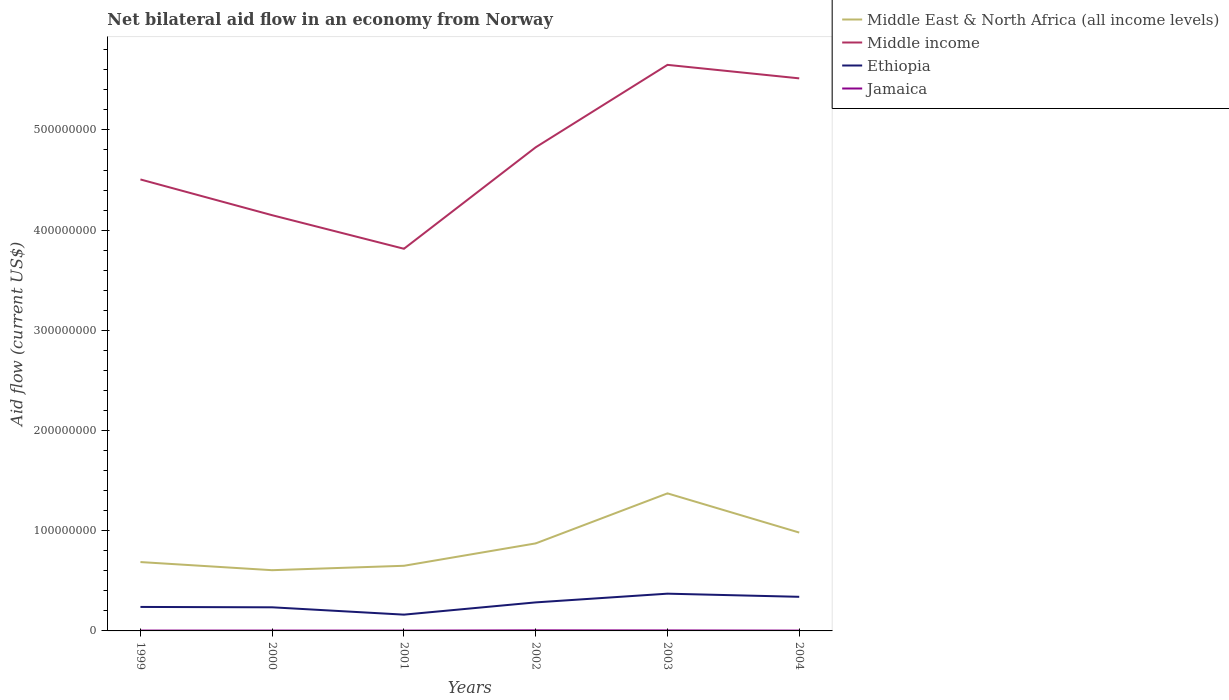How many different coloured lines are there?
Ensure brevity in your answer.  4. Does the line corresponding to Middle East & North Africa (all income levels) intersect with the line corresponding to Middle income?
Keep it short and to the point. No. Is the number of lines equal to the number of legend labels?
Your answer should be very brief. Yes. Across all years, what is the maximum net bilateral aid flow in Ethiopia?
Keep it short and to the point. 1.62e+07. What is the total net bilateral aid flow in Middle income in the graph?
Keep it short and to the point. 3.35e+07. What is the difference between the highest and the second highest net bilateral aid flow in Middle income?
Your response must be concise. 1.84e+08. Is the net bilateral aid flow in Middle East & North Africa (all income levels) strictly greater than the net bilateral aid flow in Jamaica over the years?
Offer a very short reply. No. How many years are there in the graph?
Offer a very short reply. 6. What is the difference between two consecutive major ticks on the Y-axis?
Give a very brief answer. 1.00e+08. Does the graph contain grids?
Provide a short and direct response. No. Where does the legend appear in the graph?
Keep it short and to the point. Top right. What is the title of the graph?
Your response must be concise. Net bilateral aid flow in an economy from Norway. Does "Tuvalu" appear as one of the legend labels in the graph?
Make the answer very short. No. What is the label or title of the X-axis?
Provide a succinct answer. Years. What is the label or title of the Y-axis?
Your answer should be very brief. Aid flow (current US$). What is the Aid flow (current US$) in Middle East & North Africa (all income levels) in 1999?
Your answer should be very brief. 6.87e+07. What is the Aid flow (current US$) of Middle income in 1999?
Ensure brevity in your answer.  4.51e+08. What is the Aid flow (current US$) of Ethiopia in 1999?
Offer a very short reply. 2.39e+07. What is the Aid flow (current US$) of Jamaica in 1999?
Ensure brevity in your answer.  3.60e+05. What is the Aid flow (current US$) of Middle East & North Africa (all income levels) in 2000?
Ensure brevity in your answer.  6.06e+07. What is the Aid flow (current US$) in Middle income in 2000?
Ensure brevity in your answer.  4.15e+08. What is the Aid flow (current US$) in Ethiopia in 2000?
Your answer should be compact. 2.36e+07. What is the Aid flow (current US$) of Jamaica in 2000?
Provide a short and direct response. 3.60e+05. What is the Aid flow (current US$) of Middle East & North Africa (all income levels) in 2001?
Your answer should be compact. 6.50e+07. What is the Aid flow (current US$) of Middle income in 2001?
Offer a terse response. 3.81e+08. What is the Aid flow (current US$) in Ethiopia in 2001?
Your answer should be compact. 1.62e+07. What is the Aid flow (current US$) in Middle East & North Africa (all income levels) in 2002?
Your answer should be very brief. 8.74e+07. What is the Aid flow (current US$) of Middle income in 2002?
Offer a terse response. 4.83e+08. What is the Aid flow (current US$) of Ethiopia in 2002?
Offer a very short reply. 2.85e+07. What is the Aid flow (current US$) in Jamaica in 2002?
Your response must be concise. 5.70e+05. What is the Aid flow (current US$) of Middle East & North Africa (all income levels) in 2003?
Ensure brevity in your answer.  1.37e+08. What is the Aid flow (current US$) of Middle income in 2003?
Offer a terse response. 5.65e+08. What is the Aid flow (current US$) of Ethiopia in 2003?
Offer a terse response. 3.72e+07. What is the Aid flow (current US$) in Jamaica in 2003?
Keep it short and to the point. 5.00e+05. What is the Aid flow (current US$) of Middle East & North Africa (all income levels) in 2004?
Make the answer very short. 9.82e+07. What is the Aid flow (current US$) in Middle income in 2004?
Offer a very short reply. 5.52e+08. What is the Aid flow (current US$) in Ethiopia in 2004?
Your response must be concise. 3.40e+07. What is the Aid flow (current US$) in Jamaica in 2004?
Give a very brief answer. 3.30e+05. Across all years, what is the maximum Aid flow (current US$) in Middle East & North Africa (all income levels)?
Keep it short and to the point. 1.37e+08. Across all years, what is the maximum Aid flow (current US$) of Middle income?
Make the answer very short. 5.65e+08. Across all years, what is the maximum Aid flow (current US$) of Ethiopia?
Keep it short and to the point. 3.72e+07. Across all years, what is the maximum Aid flow (current US$) of Jamaica?
Keep it short and to the point. 5.70e+05. Across all years, what is the minimum Aid flow (current US$) of Middle East & North Africa (all income levels)?
Your response must be concise. 6.06e+07. Across all years, what is the minimum Aid flow (current US$) of Middle income?
Provide a short and direct response. 3.81e+08. Across all years, what is the minimum Aid flow (current US$) of Ethiopia?
Offer a very short reply. 1.62e+07. Across all years, what is the minimum Aid flow (current US$) of Jamaica?
Your answer should be compact. 3.10e+05. What is the total Aid flow (current US$) in Middle East & North Africa (all income levels) in the graph?
Your response must be concise. 5.17e+08. What is the total Aid flow (current US$) in Middle income in the graph?
Keep it short and to the point. 2.85e+09. What is the total Aid flow (current US$) of Ethiopia in the graph?
Provide a succinct answer. 1.63e+08. What is the total Aid flow (current US$) of Jamaica in the graph?
Provide a succinct answer. 2.43e+06. What is the difference between the Aid flow (current US$) of Middle East & North Africa (all income levels) in 1999 and that in 2000?
Your response must be concise. 8.12e+06. What is the difference between the Aid flow (current US$) in Middle income in 1999 and that in 2000?
Ensure brevity in your answer.  3.57e+07. What is the difference between the Aid flow (current US$) in Ethiopia in 1999 and that in 2000?
Keep it short and to the point. 3.60e+05. What is the difference between the Aid flow (current US$) of Jamaica in 1999 and that in 2000?
Your answer should be compact. 0. What is the difference between the Aid flow (current US$) of Middle East & North Africa (all income levels) in 1999 and that in 2001?
Keep it short and to the point. 3.72e+06. What is the difference between the Aid flow (current US$) of Middle income in 1999 and that in 2001?
Make the answer very short. 6.92e+07. What is the difference between the Aid flow (current US$) in Ethiopia in 1999 and that in 2001?
Ensure brevity in your answer.  7.68e+06. What is the difference between the Aid flow (current US$) of Jamaica in 1999 and that in 2001?
Provide a succinct answer. 5.00e+04. What is the difference between the Aid flow (current US$) in Middle East & North Africa (all income levels) in 1999 and that in 2002?
Provide a short and direct response. -1.86e+07. What is the difference between the Aid flow (current US$) of Middle income in 1999 and that in 2002?
Give a very brief answer. -3.21e+07. What is the difference between the Aid flow (current US$) of Ethiopia in 1999 and that in 2002?
Ensure brevity in your answer.  -4.55e+06. What is the difference between the Aid flow (current US$) in Middle East & North Africa (all income levels) in 1999 and that in 2003?
Offer a very short reply. -6.86e+07. What is the difference between the Aid flow (current US$) in Middle income in 1999 and that in 2003?
Provide a succinct answer. -1.14e+08. What is the difference between the Aid flow (current US$) of Ethiopia in 1999 and that in 2003?
Give a very brief answer. -1.32e+07. What is the difference between the Aid flow (current US$) in Middle East & North Africa (all income levels) in 1999 and that in 2004?
Ensure brevity in your answer.  -2.94e+07. What is the difference between the Aid flow (current US$) in Middle income in 1999 and that in 2004?
Offer a very short reply. -1.01e+08. What is the difference between the Aid flow (current US$) in Ethiopia in 1999 and that in 2004?
Provide a short and direct response. -1.01e+07. What is the difference between the Aid flow (current US$) in Middle East & North Africa (all income levels) in 2000 and that in 2001?
Your response must be concise. -4.40e+06. What is the difference between the Aid flow (current US$) of Middle income in 2000 and that in 2001?
Keep it short and to the point. 3.35e+07. What is the difference between the Aid flow (current US$) in Ethiopia in 2000 and that in 2001?
Offer a terse response. 7.32e+06. What is the difference between the Aid flow (current US$) of Jamaica in 2000 and that in 2001?
Offer a very short reply. 5.00e+04. What is the difference between the Aid flow (current US$) in Middle East & North Africa (all income levels) in 2000 and that in 2002?
Ensure brevity in your answer.  -2.68e+07. What is the difference between the Aid flow (current US$) of Middle income in 2000 and that in 2002?
Offer a very short reply. -6.78e+07. What is the difference between the Aid flow (current US$) in Ethiopia in 2000 and that in 2002?
Provide a short and direct response. -4.91e+06. What is the difference between the Aid flow (current US$) in Jamaica in 2000 and that in 2002?
Your response must be concise. -2.10e+05. What is the difference between the Aid flow (current US$) in Middle East & North Africa (all income levels) in 2000 and that in 2003?
Your answer should be very brief. -7.67e+07. What is the difference between the Aid flow (current US$) in Middle income in 2000 and that in 2003?
Your answer should be very brief. -1.50e+08. What is the difference between the Aid flow (current US$) in Ethiopia in 2000 and that in 2003?
Give a very brief answer. -1.36e+07. What is the difference between the Aid flow (current US$) in Jamaica in 2000 and that in 2003?
Provide a short and direct response. -1.40e+05. What is the difference between the Aid flow (current US$) in Middle East & North Africa (all income levels) in 2000 and that in 2004?
Make the answer very short. -3.76e+07. What is the difference between the Aid flow (current US$) in Middle income in 2000 and that in 2004?
Provide a succinct answer. -1.37e+08. What is the difference between the Aid flow (current US$) in Ethiopia in 2000 and that in 2004?
Offer a terse response. -1.05e+07. What is the difference between the Aid flow (current US$) in Jamaica in 2000 and that in 2004?
Your response must be concise. 3.00e+04. What is the difference between the Aid flow (current US$) in Middle East & North Africa (all income levels) in 2001 and that in 2002?
Offer a terse response. -2.24e+07. What is the difference between the Aid flow (current US$) in Middle income in 2001 and that in 2002?
Your answer should be compact. -1.01e+08. What is the difference between the Aid flow (current US$) of Ethiopia in 2001 and that in 2002?
Give a very brief answer. -1.22e+07. What is the difference between the Aid flow (current US$) of Jamaica in 2001 and that in 2002?
Provide a short and direct response. -2.60e+05. What is the difference between the Aid flow (current US$) of Middle East & North Africa (all income levels) in 2001 and that in 2003?
Your answer should be compact. -7.23e+07. What is the difference between the Aid flow (current US$) in Middle income in 2001 and that in 2003?
Give a very brief answer. -1.84e+08. What is the difference between the Aid flow (current US$) of Ethiopia in 2001 and that in 2003?
Offer a very short reply. -2.09e+07. What is the difference between the Aid flow (current US$) in Jamaica in 2001 and that in 2003?
Your answer should be very brief. -1.90e+05. What is the difference between the Aid flow (current US$) in Middle East & North Africa (all income levels) in 2001 and that in 2004?
Your answer should be compact. -3.32e+07. What is the difference between the Aid flow (current US$) of Middle income in 2001 and that in 2004?
Your response must be concise. -1.70e+08. What is the difference between the Aid flow (current US$) in Ethiopia in 2001 and that in 2004?
Your answer should be compact. -1.78e+07. What is the difference between the Aid flow (current US$) of Middle East & North Africa (all income levels) in 2002 and that in 2003?
Make the answer very short. -4.99e+07. What is the difference between the Aid flow (current US$) in Middle income in 2002 and that in 2003?
Your answer should be very brief. -8.23e+07. What is the difference between the Aid flow (current US$) in Ethiopia in 2002 and that in 2003?
Ensure brevity in your answer.  -8.70e+06. What is the difference between the Aid flow (current US$) of Middle East & North Africa (all income levels) in 2002 and that in 2004?
Offer a very short reply. -1.08e+07. What is the difference between the Aid flow (current US$) in Middle income in 2002 and that in 2004?
Ensure brevity in your answer.  -6.88e+07. What is the difference between the Aid flow (current US$) of Ethiopia in 2002 and that in 2004?
Offer a very short reply. -5.56e+06. What is the difference between the Aid flow (current US$) of Jamaica in 2002 and that in 2004?
Offer a very short reply. 2.40e+05. What is the difference between the Aid flow (current US$) in Middle East & North Africa (all income levels) in 2003 and that in 2004?
Your response must be concise. 3.91e+07. What is the difference between the Aid flow (current US$) of Middle income in 2003 and that in 2004?
Your answer should be very brief. 1.35e+07. What is the difference between the Aid flow (current US$) of Ethiopia in 2003 and that in 2004?
Keep it short and to the point. 3.14e+06. What is the difference between the Aid flow (current US$) in Jamaica in 2003 and that in 2004?
Your response must be concise. 1.70e+05. What is the difference between the Aid flow (current US$) in Middle East & North Africa (all income levels) in 1999 and the Aid flow (current US$) in Middle income in 2000?
Your response must be concise. -3.46e+08. What is the difference between the Aid flow (current US$) in Middle East & North Africa (all income levels) in 1999 and the Aid flow (current US$) in Ethiopia in 2000?
Give a very brief answer. 4.52e+07. What is the difference between the Aid flow (current US$) in Middle East & North Africa (all income levels) in 1999 and the Aid flow (current US$) in Jamaica in 2000?
Your answer should be very brief. 6.84e+07. What is the difference between the Aid flow (current US$) in Middle income in 1999 and the Aid flow (current US$) in Ethiopia in 2000?
Your response must be concise. 4.27e+08. What is the difference between the Aid flow (current US$) of Middle income in 1999 and the Aid flow (current US$) of Jamaica in 2000?
Ensure brevity in your answer.  4.50e+08. What is the difference between the Aid flow (current US$) in Ethiopia in 1999 and the Aid flow (current US$) in Jamaica in 2000?
Provide a succinct answer. 2.36e+07. What is the difference between the Aid flow (current US$) of Middle East & North Africa (all income levels) in 1999 and the Aid flow (current US$) of Middle income in 2001?
Keep it short and to the point. -3.13e+08. What is the difference between the Aid flow (current US$) in Middle East & North Africa (all income levels) in 1999 and the Aid flow (current US$) in Ethiopia in 2001?
Make the answer very short. 5.25e+07. What is the difference between the Aid flow (current US$) of Middle East & North Africa (all income levels) in 1999 and the Aid flow (current US$) of Jamaica in 2001?
Keep it short and to the point. 6.84e+07. What is the difference between the Aid flow (current US$) of Middle income in 1999 and the Aid flow (current US$) of Ethiopia in 2001?
Your answer should be very brief. 4.34e+08. What is the difference between the Aid flow (current US$) in Middle income in 1999 and the Aid flow (current US$) in Jamaica in 2001?
Ensure brevity in your answer.  4.50e+08. What is the difference between the Aid flow (current US$) of Ethiopia in 1999 and the Aid flow (current US$) of Jamaica in 2001?
Provide a succinct answer. 2.36e+07. What is the difference between the Aid flow (current US$) in Middle East & North Africa (all income levels) in 1999 and the Aid flow (current US$) in Middle income in 2002?
Make the answer very short. -4.14e+08. What is the difference between the Aid flow (current US$) in Middle East & North Africa (all income levels) in 1999 and the Aid flow (current US$) in Ethiopia in 2002?
Give a very brief answer. 4.02e+07. What is the difference between the Aid flow (current US$) in Middle East & North Africa (all income levels) in 1999 and the Aid flow (current US$) in Jamaica in 2002?
Offer a very short reply. 6.82e+07. What is the difference between the Aid flow (current US$) of Middle income in 1999 and the Aid flow (current US$) of Ethiopia in 2002?
Provide a short and direct response. 4.22e+08. What is the difference between the Aid flow (current US$) of Middle income in 1999 and the Aid flow (current US$) of Jamaica in 2002?
Your response must be concise. 4.50e+08. What is the difference between the Aid flow (current US$) in Ethiopia in 1999 and the Aid flow (current US$) in Jamaica in 2002?
Your answer should be compact. 2.34e+07. What is the difference between the Aid flow (current US$) in Middle East & North Africa (all income levels) in 1999 and the Aid flow (current US$) in Middle income in 2003?
Provide a succinct answer. -4.96e+08. What is the difference between the Aid flow (current US$) in Middle East & North Africa (all income levels) in 1999 and the Aid flow (current US$) in Ethiopia in 2003?
Ensure brevity in your answer.  3.16e+07. What is the difference between the Aid flow (current US$) in Middle East & North Africa (all income levels) in 1999 and the Aid flow (current US$) in Jamaica in 2003?
Your answer should be compact. 6.82e+07. What is the difference between the Aid flow (current US$) in Middle income in 1999 and the Aid flow (current US$) in Ethiopia in 2003?
Provide a short and direct response. 4.13e+08. What is the difference between the Aid flow (current US$) in Middle income in 1999 and the Aid flow (current US$) in Jamaica in 2003?
Make the answer very short. 4.50e+08. What is the difference between the Aid flow (current US$) of Ethiopia in 1999 and the Aid flow (current US$) of Jamaica in 2003?
Offer a terse response. 2.34e+07. What is the difference between the Aid flow (current US$) in Middle East & North Africa (all income levels) in 1999 and the Aid flow (current US$) in Middle income in 2004?
Your answer should be very brief. -4.83e+08. What is the difference between the Aid flow (current US$) in Middle East & North Africa (all income levels) in 1999 and the Aid flow (current US$) in Ethiopia in 2004?
Provide a short and direct response. 3.47e+07. What is the difference between the Aid flow (current US$) of Middle East & North Africa (all income levels) in 1999 and the Aid flow (current US$) of Jamaica in 2004?
Provide a short and direct response. 6.84e+07. What is the difference between the Aid flow (current US$) in Middle income in 1999 and the Aid flow (current US$) in Ethiopia in 2004?
Offer a very short reply. 4.17e+08. What is the difference between the Aid flow (current US$) of Middle income in 1999 and the Aid flow (current US$) of Jamaica in 2004?
Your response must be concise. 4.50e+08. What is the difference between the Aid flow (current US$) of Ethiopia in 1999 and the Aid flow (current US$) of Jamaica in 2004?
Provide a succinct answer. 2.36e+07. What is the difference between the Aid flow (current US$) of Middle East & North Africa (all income levels) in 2000 and the Aid flow (current US$) of Middle income in 2001?
Ensure brevity in your answer.  -3.21e+08. What is the difference between the Aid flow (current US$) in Middle East & North Africa (all income levels) in 2000 and the Aid flow (current US$) in Ethiopia in 2001?
Make the answer very short. 4.44e+07. What is the difference between the Aid flow (current US$) in Middle East & North Africa (all income levels) in 2000 and the Aid flow (current US$) in Jamaica in 2001?
Provide a succinct answer. 6.03e+07. What is the difference between the Aid flow (current US$) of Middle income in 2000 and the Aid flow (current US$) of Ethiopia in 2001?
Give a very brief answer. 3.99e+08. What is the difference between the Aid flow (current US$) of Middle income in 2000 and the Aid flow (current US$) of Jamaica in 2001?
Offer a very short reply. 4.15e+08. What is the difference between the Aid flow (current US$) in Ethiopia in 2000 and the Aid flow (current US$) in Jamaica in 2001?
Make the answer very short. 2.33e+07. What is the difference between the Aid flow (current US$) of Middle East & North Africa (all income levels) in 2000 and the Aid flow (current US$) of Middle income in 2002?
Provide a short and direct response. -4.22e+08. What is the difference between the Aid flow (current US$) in Middle East & North Africa (all income levels) in 2000 and the Aid flow (current US$) in Ethiopia in 2002?
Offer a terse response. 3.21e+07. What is the difference between the Aid flow (current US$) in Middle East & North Africa (all income levels) in 2000 and the Aid flow (current US$) in Jamaica in 2002?
Your answer should be compact. 6.00e+07. What is the difference between the Aid flow (current US$) of Middle income in 2000 and the Aid flow (current US$) of Ethiopia in 2002?
Offer a terse response. 3.86e+08. What is the difference between the Aid flow (current US$) of Middle income in 2000 and the Aid flow (current US$) of Jamaica in 2002?
Ensure brevity in your answer.  4.14e+08. What is the difference between the Aid flow (current US$) in Ethiopia in 2000 and the Aid flow (current US$) in Jamaica in 2002?
Your response must be concise. 2.30e+07. What is the difference between the Aid flow (current US$) in Middle East & North Africa (all income levels) in 2000 and the Aid flow (current US$) in Middle income in 2003?
Provide a succinct answer. -5.04e+08. What is the difference between the Aid flow (current US$) of Middle East & North Africa (all income levels) in 2000 and the Aid flow (current US$) of Ethiopia in 2003?
Provide a short and direct response. 2.34e+07. What is the difference between the Aid flow (current US$) of Middle East & North Africa (all income levels) in 2000 and the Aid flow (current US$) of Jamaica in 2003?
Your answer should be compact. 6.01e+07. What is the difference between the Aid flow (current US$) of Middle income in 2000 and the Aid flow (current US$) of Ethiopia in 2003?
Provide a short and direct response. 3.78e+08. What is the difference between the Aid flow (current US$) of Middle income in 2000 and the Aid flow (current US$) of Jamaica in 2003?
Provide a short and direct response. 4.14e+08. What is the difference between the Aid flow (current US$) in Ethiopia in 2000 and the Aid flow (current US$) in Jamaica in 2003?
Provide a short and direct response. 2.31e+07. What is the difference between the Aid flow (current US$) in Middle East & North Africa (all income levels) in 2000 and the Aid flow (current US$) in Middle income in 2004?
Give a very brief answer. -4.91e+08. What is the difference between the Aid flow (current US$) in Middle East & North Africa (all income levels) in 2000 and the Aid flow (current US$) in Ethiopia in 2004?
Offer a terse response. 2.66e+07. What is the difference between the Aid flow (current US$) of Middle East & North Africa (all income levels) in 2000 and the Aid flow (current US$) of Jamaica in 2004?
Your response must be concise. 6.03e+07. What is the difference between the Aid flow (current US$) of Middle income in 2000 and the Aid flow (current US$) of Ethiopia in 2004?
Your answer should be compact. 3.81e+08. What is the difference between the Aid flow (current US$) in Middle income in 2000 and the Aid flow (current US$) in Jamaica in 2004?
Make the answer very short. 4.15e+08. What is the difference between the Aid flow (current US$) in Ethiopia in 2000 and the Aid flow (current US$) in Jamaica in 2004?
Offer a very short reply. 2.32e+07. What is the difference between the Aid flow (current US$) in Middle East & North Africa (all income levels) in 2001 and the Aid flow (current US$) in Middle income in 2002?
Provide a succinct answer. -4.18e+08. What is the difference between the Aid flow (current US$) of Middle East & North Africa (all income levels) in 2001 and the Aid flow (current US$) of Ethiopia in 2002?
Your answer should be very brief. 3.65e+07. What is the difference between the Aid flow (current US$) in Middle East & North Africa (all income levels) in 2001 and the Aid flow (current US$) in Jamaica in 2002?
Provide a short and direct response. 6.44e+07. What is the difference between the Aid flow (current US$) of Middle income in 2001 and the Aid flow (current US$) of Ethiopia in 2002?
Provide a succinct answer. 3.53e+08. What is the difference between the Aid flow (current US$) in Middle income in 2001 and the Aid flow (current US$) in Jamaica in 2002?
Provide a succinct answer. 3.81e+08. What is the difference between the Aid flow (current US$) in Ethiopia in 2001 and the Aid flow (current US$) in Jamaica in 2002?
Ensure brevity in your answer.  1.57e+07. What is the difference between the Aid flow (current US$) in Middle East & North Africa (all income levels) in 2001 and the Aid flow (current US$) in Middle income in 2003?
Offer a very short reply. -5.00e+08. What is the difference between the Aid flow (current US$) in Middle East & North Africa (all income levels) in 2001 and the Aid flow (current US$) in Ethiopia in 2003?
Make the answer very short. 2.78e+07. What is the difference between the Aid flow (current US$) in Middle East & North Africa (all income levels) in 2001 and the Aid flow (current US$) in Jamaica in 2003?
Give a very brief answer. 6.45e+07. What is the difference between the Aid flow (current US$) in Middle income in 2001 and the Aid flow (current US$) in Ethiopia in 2003?
Offer a very short reply. 3.44e+08. What is the difference between the Aid flow (current US$) in Middle income in 2001 and the Aid flow (current US$) in Jamaica in 2003?
Offer a terse response. 3.81e+08. What is the difference between the Aid flow (current US$) of Ethiopia in 2001 and the Aid flow (current US$) of Jamaica in 2003?
Keep it short and to the point. 1.58e+07. What is the difference between the Aid flow (current US$) of Middle East & North Africa (all income levels) in 2001 and the Aid flow (current US$) of Middle income in 2004?
Ensure brevity in your answer.  -4.86e+08. What is the difference between the Aid flow (current US$) of Middle East & North Africa (all income levels) in 2001 and the Aid flow (current US$) of Ethiopia in 2004?
Provide a succinct answer. 3.10e+07. What is the difference between the Aid flow (current US$) of Middle East & North Africa (all income levels) in 2001 and the Aid flow (current US$) of Jamaica in 2004?
Your answer should be very brief. 6.47e+07. What is the difference between the Aid flow (current US$) in Middle income in 2001 and the Aid flow (current US$) in Ethiopia in 2004?
Keep it short and to the point. 3.47e+08. What is the difference between the Aid flow (current US$) in Middle income in 2001 and the Aid flow (current US$) in Jamaica in 2004?
Your answer should be compact. 3.81e+08. What is the difference between the Aid flow (current US$) in Ethiopia in 2001 and the Aid flow (current US$) in Jamaica in 2004?
Offer a very short reply. 1.59e+07. What is the difference between the Aid flow (current US$) of Middle East & North Africa (all income levels) in 2002 and the Aid flow (current US$) of Middle income in 2003?
Provide a succinct answer. -4.78e+08. What is the difference between the Aid flow (current US$) of Middle East & North Africa (all income levels) in 2002 and the Aid flow (current US$) of Ethiopia in 2003?
Provide a short and direct response. 5.02e+07. What is the difference between the Aid flow (current US$) of Middle East & North Africa (all income levels) in 2002 and the Aid flow (current US$) of Jamaica in 2003?
Your answer should be compact. 8.69e+07. What is the difference between the Aid flow (current US$) in Middle income in 2002 and the Aid flow (current US$) in Ethiopia in 2003?
Offer a very short reply. 4.46e+08. What is the difference between the Aid flow (current US$) in Middle income in 2002 and the Aid flow (current US$) in Jamaica in 2003?
Keep it short and to the point. 4.82e+08. What is the difference between the Aid flow (current US$) in Ethiopia in 2002 and the Aid flow (current US$) in Jamaica in 2003?
Ensure brevity in your answer.  2.80e+07. What is the difference between the Aid flow (current US$) in Middle East & North Africa (all income levels) in 2002 and the Aid flow (current US$) in Middle income in 2004?
Give a very brief answer. -4.64e+08. What is the difference between the Aid flow (current US$) in Middle East & North Africa (all income levels) in 2002 and the Aid flow (current US$) in Ethiopia in 2004?
Keep it short and to the point. 5.33e+07. What is the difference between the Aid flow (current US$) in Middle East & North Africa (all income levels) in 2002 and the Aid flow (current US$) in Jamaica in 2004?
Your answer should be very brief. 8.70e+07. What is the difference between the Aid flow (current US$) of Middle income in 2002 and the Aid flow (current US$) of Ethiopia in 2004?
Your answer should be very brief. 4.49e+08. What is the difference between the Aid flow (current US$) of Middle income in 2002 and the Aid flow (current US$) of Jamaica in 2004?
Your answer should be very brief. 4.82e+08. What is the difference between the Aid flow (current US$) in Ethiopia in 2002 and the Aid flow (current US$) in Jamaica in 2004?
Your answer should be very brief. 2.82e+07. What is the difference between the Aid flow (current US$) of Middle East & North Africa (all income levels) in 2003 and the Aid flow (current US$) of Middle income in 2004?
Keep it short and to the point. -4.14e+08. What is the difference between the Aid flow (current US$) of Middle East & North Africa (all income levels) in 2003 and the Aid flow (current US$) of Ethiopia in 2004?
Provide a succinct answer. 1.03e+08. What is the difference between the Aid flow (current US$) of Middle East & North Africa (all income levels) in 2003 and the Aid flow (current US$) of Jamaica in 2004?
Offer a very short reply. 1.37e+08. What is the difference between the Aid flow (current US$) in Middle income in 2003 and the Aid flow (current US$) in Ethiopia in 2004?
Ensure brevity in your answer.  5.31e+08. What is the difference between the Aid flow (current US$) in Middle income in 2003 and the Aid flow (current US$) in Jamaica in 2004?
Provide a short and direct response. 5.65e+08. What is the difference between the Aid flow (current US$) in Ethiopia in 2003 and the Aid flow (current US$) in Jamaica in 2004?
Your answer should be very brief. 3.68e+07. What is the average Aid flow (current US$) of Middle East & North Africa (all income levels) per year?
Offer a very short reply. 8.62e+07. What is the average Aid flow (current US$) in Middle income per year?
Provide a short and direct response. 4.74e+08. What is the average Aid flow (current US$) of Ethiopia per year?
Your response must be concise. 2.72e+07. What is the average Aid flow (current US$) of Jamaica per year?
Your answer should be very brief. 4.05e+05. In the year 1999, what is the difference between the Aid flow (current US$) of Middle East & North Africa (all income levels) and Aid flow (current US$) of Middle income?
Your answer should be very brief. -3.82e+08. In the year 1999, what is the difference between the Aid flow (current US$) of Middle East & North Africa (all income levels) and Aid flow (current US$) of Ethiopia?
Keep it short and to the point. 4.48e+07. In the year 1999, what is the difference between the Aid flow (current US$) of Middle East & North Africa (all income levels) and Aid flow (current US$) of Jamaica?
Offer a very short reply. 6.84e+07. In the year 1999, what is the difference between the Aid flow (current US$) in Middle income and Aid flow (current US$) in Ethiopia?
Provide a short and direct response. 4.27e+08. In the year 1999, what is the difference between the Aid flow (current US$) in Middle income and Aid flow (current US$) in Jamaica?
Your answer should be very brief. 4.50e+08. In the year 1999, what is the difference between the Aid flow (current US$) in Ethiopia and Aid flow (current US$) in Jamaica?
Ensure brevity in your answer.  2.36e+07. In the year 2000, what is the difference between the Aid flow (current US$) of Middle East & North Africa (all income levels) and Aid flow (current US$) of Middle income?
Ensure brevity in your answer.  -3.54e+08. In the year 2000, what is the difference between the Aid flow (current US$) of Middle East & North Africa (all income levels) and Aid flow (current US$) of Ethiopia?
Your response must be concise. 3.70e+07. In the year 2000, what is the difference between the Aid flow (current US$) in Middle East & North Africa (all income levels) and Aid flow (current US$) in Jamaica?
Your answer should be very brief. 6.02e+07. In the year 2000, what is the difference between the Aid flow (current US$) in Middle income and Aid flow (current US$) in Ethiopia?
Make the answer very short. 3.91e+08. In the year 2000, what is the difference between the Aid flow (current US$) of Middle income and Aid flow (current US$) of Jamaica?
Keep it short and to the point. 4.15e+08. In the year 2000, what is the difference between the Aid flow (current US$) of Ethiopia and Aid flow (current US$) of Jamaica?
Offer a very short reply. 2.32e+07. In the year 2001, what is the difference between the Aid flow (current US$) of Middle East & North Africa (all income levels) and Aid flow (current US$) of Middle income?
Make the answer very short. -3.16e+08. In the year 2001, what is the difference between the Aid flow (current US$) in Middle East & North Africa (all income levels) and Aid flow (current US$) in Ethiopia?
Make the answer very short. 4.88e+07. In the year 2001, what is the difference between the Aid flow (current US$) in Middle East & North Africa (all income levels) and Aid flow (current US$) in Jamaica?
Give a very brief answer. 6.47e+07. In the year 2001, what is the difference between the Aid flow (current US$) in Middle income and Aid flow (current US$) in Ethiopia?
Your response must be concise. 3.65e+08. In the year 2001, what is the difference between the Aid flow (current US$) in Middle income and Aid flow (current US$) in Jamaica?
Your response must be concise. 3.81e+08. In the year 2001, what is the difference between the Aid flow (current US$) in Ethiopia and Aid flow (current US$) in Jamaica?
Your answer should be compact. 1.59e+07. In the year 2002, what is the difference between the Aid flow (current US$) of Middle East & North Africa (all income levels) and Aid flow (current US$) of Middle income?
Your answer should be very brief. -3.95e+08. In the year 2002, what is the difference between the Aid flow (current US$) of Middle East & North Africa (all income levels) and Aid flow (current US$) of Ethiopia?
Provide a short and direct response. 5.89e+07. In the year 2002, what is the difference between the Aid flow (current US$) in Middle East & North Africa (all income levels) and Aid flow (current US$) in Jamaica?
Your response must be concise. 8.68e+07. In the year 2002, what is the difference between the Aid flow (current US$) of Middle income and Aid flow (current US$) of Ethiopia?
Offer a terse response. 4.54e+08. In the year 2002, what is the difference between the Aid flow (current US$) of Middle income and Aid flow (current US$) of Jamaica?
Give a very brief answer. 4.82e+08. In the year 2002, what is the difference between the Aid flow (current US$) of Ethiopia and Aid flow (current US$) of Jamaica?
Your response must be concise. 2.79e+07. In the year 2003, what is the difference between the Aid flow (current US$) of Middle East & North Africa (all income levels) and Aid flow (current US$) of Middle income?
Provide a short and direct response. -4.28e+08. In the year 2003, what is the difference between the Aid flow (current US$) of Middle East & North Africa (all income levels) and Aid flow (current US$) of Ethiopia?
Your response must be concise. 1.00e+08. In the year 2003, what is the difference between the Aid flow (current US$) of Middle East & North Africa (all income levels) and Aid flow (current US$) of Jamaica?
Provide a succinct answer. 1.37e+08. In the year 2003, what is the difference between the Aid flow (current US$) of Middle income and Aid flow (current US$) of Ethiopia?
Offer a very short reply. 5.28e+08. In the year 2003, what is the difference between the Aid flow (current US$) of Middle income and Aid flow (current US$) of Jamaica?
Your response must be concise. 5.64e+08. In the year 2003, what is the difference between the Aid flow (current US$) in Ethiopia and Aid flow (current US$) in Jamaica?
Your response must be concise. 3.67e+07. In the year 2004, what is the difference between the Aid flow (current US$) of Middle East & North Africa (all income levels) and Aid flow (current US$) of Middle income?
Offer a terse response. -4.53e+08. In the year 2004, what is the difference between the Aid flow (current US$) in Middle East & North Africa (all income levels) and Aid flow (current US$) in Ethiopia?
Ensure brevity in your answer.  6.41e+07. In the year 2004, what is the difference between the Aid flow (current US$) of Middle East & North Africa (all income levels) and Aid flow (current US$) of Jamaica?
Your answer should be very brief. 9.78e+07. In the year 2004, what is the difference between the Aid flow (current US$) of Middle income and Aid flow (current US$) of Ethiopia?
Keep it short and to the point. 5.17e+08. In the year 2004, what is the difference between the Aid flow (current US$) of Middle income and Aid flow (current US$) of Jamaica?
Keep it short and to the point. 5.51e+08. In the year 2004, what is the difference between the Aid flow (current US$) in Ethiopia and Aid flow (current US$) in Jamaica?
Make the answer very short. 3.37e+07. What is the ratio of the Aid flow (current US$) in Middle East & North Africa (all income levels) in 1999 to that in 2000?
Your answer should be very brief. 1.13. What is the ratio of the Aid flow (current US$) in Middle income in 1999 to that in 2000?
Your answer should be very brief. 1.09. What is the ratio of the Aid flow (current US$) in Ethiopia in 1999 to that in 2000?
Your answer should be compact. 1.02. What is the ratio of the Aid flow (current US$) of Middle East & North Africa (all income levels) in 1999 to that in 2001?
Offer a terse response. 1.06. What is the ratio of the Aid flow (current US$) of Middle income in 1999 to that in 2001?
Ensure brevity in your answer.  1.18. What is the ratio of the Aid flow (current US$) of Ethiopia in 1999 to that in 2001?
Provide a succinct answer. 1.47. What is the ratio of the Aid flow (current US$) of Jamaica in 1999 to that in 2001?
Keep it short and to the point. 1.16. What is the ratio of the Aid flow (current US$) in Middle East & North Africa (all income levels) in 1999 to that in 2002?
Ensure brevity in your answer.  0.79. What is the ratio of the Aid flow (current US$) in Middle income in 1999 to that in 2002?
Ensure brevity in your answer.  0.93. What is the ratio of the Aid flow (current US$) in Ethiopia in 1999 to that in 2002?
Make the answer very short. 0.84. What is the ratio of the Aid flow (current US$) in Jamaica in 1999 to that in 2002?
Offer a very short reply. 0.63. What is the ratio of the Aid flow (current US$) of Middle East & North Africa (all income levels) in 1999 to that in 2003?
Offer a very short reply. 0.5. What is the ratio of the Aid flow (current US$) of Middle income in 1999 to that in 2003?
Your answer should be very brief. 0.8. What is the ratio of the Aid flow (current US$) in Ethiopia in 1999 to that in 2003?
Ensure brevity in your answer.  0.64. What is the ratio of the Aid flow (current US$) of Jamaica in 1999 to that in 2003?
Provide a succinct answer. 0.72. What is the ratio of the Aid flow (current US$) of Middle East & North Africa (all income levels) in 1999 to that in 2004?
Ensure brevity in your answer.  0.7. What is the ratio of the Aid flow (current US$) in Middle income in 1999 to that in 2004?
Your response must be concise. 0.82. What is the ratio of the Aid flow (current US$) in Ethiopia in 1999 to that in 2004?
Offer a very short reply. 0.7. What is the ratio of the Aid flow (current US$) in Middle East & North Africa (all income levels) in 2000 to that in 2001?
Your response must be concise. 0.93. What is the ratio of the Aid flow (current US$) in Middle income in 2000 to that in 2001?
Provide a short and direct response. 1.09. What is the ratio of the Aid flow (current US$) of Ethiopia in 2000 to that in 2001?
Provide a succinct answer. 1.45. What is the ratio of the Aid flow (current US$) in Jamaica in 2000 to that in 2001?
Your answer should be very brief. 1.16. What is the ratio of the Aid flow (current US$) in Middle East & North Africa (all income levels) in 2000 to that in 2002?
Provide a short and direct response. 0.69. What is the ratio of the Aid flow (current US$) of Middle income in 2000 to that in 2002?
Offer a very short reply. 0.86. What is the ratio of the Aid flow (current US$) in Ethiopia in 2000 to that in 2002?
Offer a very short reply. 0.83. What is the ratio of the Aid flow (current US$) in Jamaica in 2000 to that in 2002?
Your answer should be very brief. 0.63. What is the ratio of the Aid flow (current US$) of Middle East & North Africa (all income levels) in 2000 to that in 2003?
Provide a succinct answer. 0.44. What is the ratio of the Aid flow (current US$) of Middle income in 2000 to that in 2003?
Offer a very short reply. 0.73. What is the ratio of the Aid flow (current US$) of Ethiopia in 2000 to that in 2003?
Provide a short and direct response. 0.63. What is the ratio of the Aid flow (current US$) of Jamaica in 2000 to that in 2003?
Ensure brevity in your answer.  0.72. What is the ratio of the Aid flow (current US$) in Middle East & North Africa (all income levels) in 2000 to that in 2004?
Give a very brief answer. 0.62. What is the ratio of the Aid flow (current US$) in Middle income in 2000 to that in 2004?
Your answer should be very brief. 0.75. What is the ratio of the Aid flow (current US$) in Ethiopia in 2000 to that in 2004?
Your response must be concise. 0.69. What is the ratio of the Aid flow (current US$) in Middle East & North Africa (all income levels) in 2001 to that in 2002?
Ensure brevity in your answer.  0.74. What is the ratio of the Aid flow (current US$) of Middle income in 2001 to that in 2002?
Your answer should be very brief. 0.79. What is the ratio of the Aid flow (current US$) of Ethiopia in 2001 to that in 2002?
Give a very brief answer. 0.57. What is the ratio of the Aid flow (current US$) in Jamaica in 2001 to that in 2002?
Offer a terse response. 0.54. What is the ratio of the Aid flow (current US$) of Middle East & North Africa (all income levels) in 2001 to that in 2003?
Provide a succinct answer. 0.47. What is the ratio of the Aid flow (current US$) of Middle income in 2001 to that in 2003?
Offer a very short reply. 0.68. What is the ratio of the Aid flow (current US$) of Ethiopia in 2001 to that in 2003?
Keep it short and to the point. 0.44. What is the ratio of the Aid flow (current US$) of Jamaica in 2001 to that in 2003?
Ensure brevity in your answer.  0.62. What is the ratio of the Aid flow (current US$) of Middle East & North Africa (all income levels) in 2001 to that in 2004?
Your answer should be compact. 0.66. What is the ratio of the Aid flow (current US$) in Middle income in 2001 to that in 2004?
Give a very brief answer. 0.69. What is the ratio of the Aid flow (current US$) in Ethiopia in 2001 to that in 2004?
Your answer should be very brief. 0.48. What is the ratio of the Aid flow (current US$) in Jamaica in 2001 to that in 2004?
Give a very brief answer. 0.94. What is the ratio of the Aid flow (current US$) of Middle East & North Africa (all income levels) in 2002 to that in 2003?
Your answer should be compact. 0.64. What is the ratio of the Aid flow (current US$) of Middle income in 2002 to that in 2003?
Provide a succinct answer. 0.85. What is the ratio of the Aid flow (current US$) of Ethiopia in 2002 to that in 2003?
Offer a terse response. 0.77. What is the ratio of the Aid flow (current US$) of Jamaica in 2002 to that in 2003?
Provide a short and direct response. 1.14. What is the ratio of the Aid flow (current US$) in Middle East & North Africa (all income levels) in 2002 to that in 2004?
Make the answer very short. 0.89. What is the ratio of the Aid flow (current US$) in Middle income in 2002 to that in 2004?
Your answer should be compact. 0.88. What is the ratio of the Aid flow (current US$) in Ethiopia in 2002 to that in 2004?
Your answer should be compact. 0.84. What is the ratio of the Aid flow (current US$) in Jamaica in 2002 to that in 2004?
Offer a terse response. 1.73. What is the ratio of the Aid flow (current US$) of Middle East & North Africa (all income levels) in 2003 to that in 2004?
Ensure brevity in your answer.  1.4. What is the ratio of the Aid flow (current US$) of Middle income in 2003 to that in 2004?
Provide a short and direct response. 1.02. What is the ratio of the Aid flow (current US$) in Ethiopia in 2003 to that in 2004?
Offer a very short reply. 1.09. What is the ratio of the Aid flow (current US$) of Jamaica in 2003 to that in 2004?
Ensure brevity in your answer.  1.52. What is the difference between the highest and the second highest Aid flow (current US$) of Middle East & North Africa (all income levels)?
Give a very brief answer. 3.91e+07. What is the difference between the highest and the second highest Aid flow (current US$) of Middle income?
Keep it short and to the point. 1.35e+07. What is the difference between the highest and the second highest Aid flow (current US$) in Ethiopia?
Your answer should be compact. 3.14e+06. What is the difference between the highest and the lowest Aid flow (current US$) in Middle East & North Africa (all income levels)?
Your answer should be compact. 7.67e+07. What is the difference between the highest and the lowest Aid flow (current US$) in Middle income?
Your answer should be compact. 1.84e+08. What is the difference between the highest and the lowest Aid flow (current US$) in Ethiopia?
Make the answer very short. 2.09e+07. What is the difference between the highest and the lowest Aid flow (current US$) in Jamaica?
Offer a very short reply. 2.60e+05. 